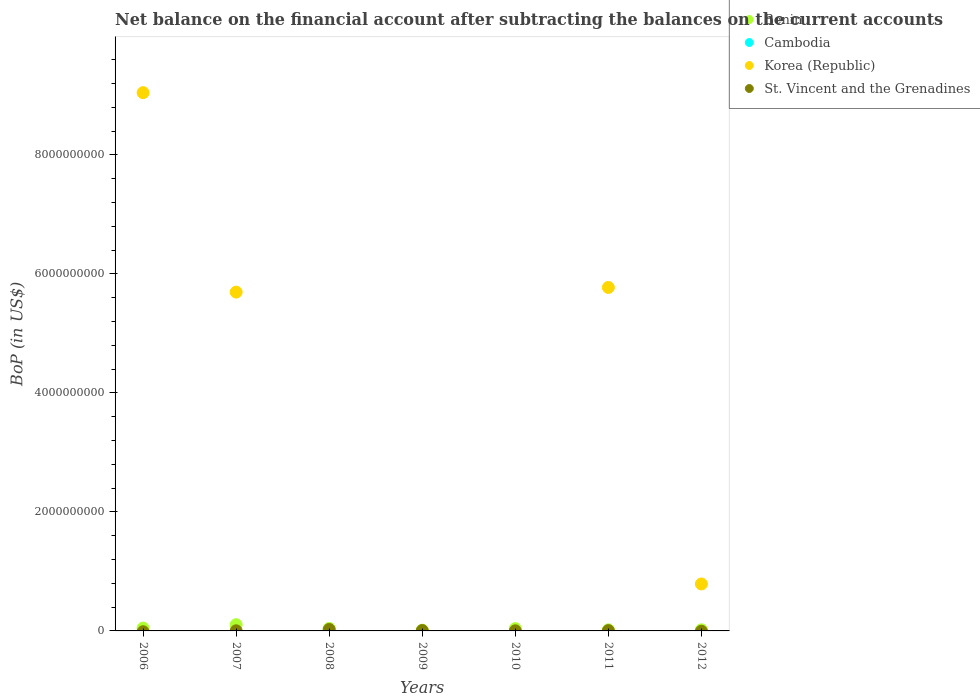How many different coloured dotlines are there?
Provide a succinct answer. 3. Is the number of dotlines equal to the number of legend labels?
Give a very brief answer. No. What is the Balance of Payments in St. Vincent and the Grenadines in 2006?
Offer a terse response. 0. Across all years, what is the maximum Balance of Payments in Korea (Republic)?
Your response must be concise. 9.05e+09. What is the total Balance of Payments in St. Vincent and the Grenadines in the graph?
Make the answer very short. 3.95e+07. What is the difference between the Balance of Payments in St. Vincent and the Grenadines in 2007 and that in 2009?
Keep it short and to the point. -4.30e+06. What is the difference between the Balance of Payments in Cambodia in 2012 and the Balance of Payments in Korea (Republic) in 2007?
Ensure brevity in your answer.  -5.69e+09. What is the average Balance of Payments in Cambodia per year?
Provide a succinct answer. 0. In the year 2012, what is the difference between the Balance of Payments in Benin and Balance of Payments in Korea (Republic)?
Keep it short and to the point. -7.71e+08. What is the ratio of the Balance of Payments in Korea (Republic) in 2007 to that in 2011?
Your answer should be very brief. 0.99. What is the difference between the highest and the second highest Balance of Payments in St. Vincent and the Grenadines?
Provide a short and direct response. 1.78e+07. What is the difference between the highest and the lowest Balance of Payments in Benin?
Your response must be concise. 9.24e+07. In how many years, is the Balance of Payments in Benin greater than the average Balance of Payments in Benin taken over all years?
Make the answer very short. 3. Is the sum of the Balance of Payments in Benin in 2007 and 2012 greater than the maximum Balance of Payments in Korea (Republic) across all years?
Keep it short and to the point. No. Does the Balance of Payments in St. Vincent and the Grenadines monotonically increase over the years?
Make the answer very short. No. Is the Balance of Payments in Cambodia strictly less than the Balance of Payments in St. Vincent and the Grenadines over the years?
Give a very brief answer. Yes. How many years are there in the graph?
Your response must be concise. 7. Are the values on the major ticks of Y-axis written in scientific E-notation?
Offer a terse response. No. How are the legend labels stacked?
Make the answer very short. Vertical. What is the title of the graph?
Your answer should be compact. Net balance on the financial account after subtracting the balances on the current accounts. What is the label or title of the Y-axis?
Provide a short and direct response. BoP (in US$). What is the BoP (in US$) in Benin in 2006?
Give a very brief answer. 4.74e+07. What is the BoP (in US$) in Cambodia in 2006?
Provide a short and direct response. 0. What is the BoP (in US$) of Korea (Republic) in 2006?
Your answer should be compact. 9.05e+09. What is the BoP (in US$) in St. Vincent and the Grenadines in 2006?
Offer a very short reply. 0. What is the BoP (in US$) of Benin in 2007?
Ensure brevity in your answer.  1.05e+08. What is the BoP (in US$) of Korea (Republic) in 2007?
Offer a terse response. 5.69e+09. What is the BoP (in US$) in St. Vincent and the Grenadines in 2007?
Give a very brief answer. 2.05e+06. What is the BoP (in US$) of Benin in 2008?
Provide a short and direct response. 4.16e+07. What is the BoP (in US$) in Cambodia in 2008?
Keep it short and to the point. 0. What is the BoP (in US$) in Korea (Republic) in 2008?
Your answer should be very brief. 0. What is the BoP (in US$) in St. Vincent and the Grenadines in 2008?
Keep it short and to the point. 2.42e+07. What is the BoP (in US$) in Benin in 2009?
Ensure brevity in your answer.  1.21e+07. What is the BoP (in US$) in Cambodia in 2009?
Ensure brevity in your answer.  0. What is the BoP (in US$) of Korea (Republic) in 2009?
Your response must be concise. 0. What is the BoP (in US$) of St. Vincent and the Grenadines in 2009?
Keep it short and to the point. 6.35e+06. What is the BoP (in US$) of Benin in 2010?
Keep it short and to the point. 3.83e+07. What is the BoP (in US$) of Korea (Republic) in 2010?
Your answer should be very brief. 0. What is the BoP (in US$) in St. Vincent and the Grenadines in 2010?
Make the answer very short. 1.79e+06. What is the BoP (in US$) in Benin in 2011?
Make the answer very short. 1.87e+07. What is the BoP (in US$) of Korea (Republic) in 2011?
Offer a very short reply. 5.77e+09. What is the BoP (in US$) of St. Vincent and the Grenadines in 2011?
Your answer should be compact. 5.15e+06. What is the BoP (in US$) of Benin in 2012?
Provide a short and direct response. 1.84e+07. What is the BoP (in US$) in Korea (Republic) in 2012?
Offer a terse response. 7.89e+08. What is the BoP (in US$) in St. Vincent and the Grenadines in 2012?
Provide a short and direct response. 0. Across all years, what is the maximum BoP (in US$) of Benin?
Provide a short and direct response. 1.05e+08. Across all years, what is the maximum BoP (in US$) of Korea (Republic)?
Your answer should be compact. 9.05e+09. Across all years, what is the maximum BoP (in US$) in St. Vincent and the Grenadines?
Provide a succinct answer. 2.42e+07. Across all years, what is the minimum BoP (in US$) of Benin?
Offer a very short reply. 1.21e+07. What is the total BoP (in US$) of Benin in the graph?
Provide a succinct answer. 2.81e+08. What is the total BoP (in US$) in Cambodia in the graph?
Keep it short and to the point. 0. What is the total BoP (in US$) in Korea (Republic) in the graph?
Make the answer very short. 2.13e+1. What is the total BoP (in US$) in St. Vincent and the Grenadines in the graph?
Provide a short and direct response. 3.95e+07. What is the difference between the BoP (in US$) in Benin in 2006 and that in 2007?
Your answer should be very brief. -5.71e+07. What is the difference between the BoP (in US$) of Korea (Republic) in 2006 and that in 2007?
Keep it short and to the point. 3.35e+09. What is the difference between the BoP (in US$) of Benin in 2006 and that in 2008?
Your answer should be very brief. 5.85e+06. What is the difference between the BoP (in US$) of Benin in 2006 and that in 2009?
Keep it short and to the point. 3.53e+07. What is the difference between the BoP (in US$) of Benin in 2006 and that in 2010?
Your answer should be very brief. 9.08e+06. What is the difference between the BoP (in US$) in Benin in 2006 and that in 2011?
Your answer should be compact. 2.87e+07. What is the difference between the BoP (in US$) in Korea (Republic) in 2006 and that in 2011?
Offer a very short reply. 3.27e+09. What is the difference between the BoP (in US$) of Benin in 2006 and that in 2012?
Your answer should be compact. 2.90e+07. What is the difference between the BoP (in US$) in Korea (Republic) in 2006 and that in 2012?
Provide a short and direct response. 8.26e+09. What is the difference between the BoP (in US$) in Benin in 2007 and that in 2008?
Offer a terse response. 6.29e+07. What is the difference between the BoP (in US$) of St. Vincent and the Grenadines in 2007 and that in 2008?
Keep it short and to the point. -2.21e+07. What is the difference between the BoP (in US$) in Benin in 2007 and that in 2009?
Offer a very short reply. 9.24e+07. What is the difference between the BoP (in US$) of St. Vincent and the Grenadines in 2007 and that in 2009?
Your response must be concise. -4.30e+06. What is the difference between the BoP (in US$) of Benin in 2007 and that in 2010?
Keep it short and to the point. 6.62e+07. What is the difference between the BoP (in US$) in St. Vincent and the Grenadines in 2007 and that in 2010?
Offer a very short reply. 2.57e+05. What is the difference between the BoP (in US$) of Benin in 2007 and that in 2011?
Offer a terse response. 8.58e+07. What is the difference between the BoP (in US$) in Korea (Republic) in 2007 and that in 2011?
Your response must be concise. -7.83e+07. What is the difference between the BoP (in US$) of St. Vincent and the Grenadines in 2007 and that in 2011?
Offer a very short reply. -3.10e+06. What is the difference between the BoP (in US$) in Benin in 2007 and that in 2012?
Your answer should be very brief. 8.61e+07. What is the difference between the BoP (in US$) of Korea (Republic) in 2007 and that in 2012?
Your response must be concise. 4.90e+09. What is the difference between the BoP (in US$) in Benin in 2008 and that in 2009?
Keep it short and to the point. 2.94e+07. What is the difference between the BoP (in US$) in St. Vincent and the Grenadines in 2008 and that in 2009?
Keep it short and to the point. 1.78e+07. What is the difference between the BoP (in US$) of Benin in 2008 and that in 2010?
Offer a very short reply. 3.22e+06. What is the difference between the BoP (in US$) of St. Vincent and the Grenadines in 2008 and that in 2010?
Make the answer very short. 2.24e+07. What is the difference between the BoP (in US$) in Benin in 2008 and that in 2011?
Offer a terse response. 2.28e+07. What is the difference between the BoP (in US$) in St. Vincent and the Grenadines in 2008 and that in 2011?
Provide a succinct answer. 1.90e+07. What is the difference between the BoP (in US$) in Benin in 2008 and that in 2012?
Make the answer very short. 2.32e+07. What is the difference between the BoP (in US$) of Benin in 2009 and that in 2010?
Offer a very short reply. -2.62e+07. What is the difference between the BoP (in US$) in St. Vincent and the Grenadines in 2009 and that in 2010?
Make the answer very short. 4.56e+06. What is the difference between the BoP (in US$) of Benin in 2009 and that in 2011?
Provide a short and direct response. -6.57e+06. What is the difference between the BoP (in US$) of St. Vincent and the Grenadines in 2009 and that in 2011?
Your answer should be very brief. 1.20e+06. What is the difference between the BoP (in US$) in Benin in 2009 and that in 2012?
Keep it short and to the point. -6.25e+06. What is the difference between the BoP (in US$) in Benin in 2010 and that in 2011?
Ensure brevity in your answer.  1.96e+07. What is the difference between the BoP (in US$) of St. Vincent and the Grenadines in 2010 and that in 2011?
Your answer should be very brief. -3.36e+06. What is the difference between the BoP (in US$) of Benin in 2010 and that in 2012?
Provide a short and direct response. 1.99e+07. What is the difference between the BoP (in US$) of Benin in 2011 and that in 2012?
Give a very brief answer. 3.23e+05. What is the difference between the BoP (in US$) in Korea (Republic) in 2011 and that in 2012?
Provide a short and direct response. 4.98e+09. What is the difference between the BoP (in US$) of Benin in 2006 and the BoP (in US$) of Korea (Republic) in 2007?
Offer a very short reply. -5.65e+09. What is the difference between the BoP (in US$) in Benin in 2006 and the BoP (in US$) in St. Vincent and the Grenadines in 2007?
Your answer should be very brief. 4.54e+07. What is the difference between the BoP (in US$) of Korea (Republic) in 2006 and the BoP (in US$) of St. Vincent and the Grenadines in 2007?
Provide a succinct answer. 9.04e+09. What is the difference between the BoP (in US$) of Benin in 2006 and the BoP (in US$) of St. Vincent and the Grenadines in 2008?
Ensure brevity in your answer.  2.32e+07. What is the difference between the BoP (in US$) in Korea (Republic) in 2006 and the BoP (in US$) in St. Vincent and the Grenadines in 2008?
Ensure brevity in your answer.  9.02e+09. What is the difference between the BoP (in US$) in Benin in 2006 and the BoP (in US$) in St. Vincent and the Grenadines in 2009?
Provide a short and direct response. 4.11e+07. What is the difference between the BoP (in US$) in Korea (Republic) in 2006 and the BoP (in US$) in St. Vincent and the Grenadines in 2009?
Your answer should be very brief. 9.04e+09. What is the difference between the BoP (in US$) in Benin in 2006 and the BoP (in US$) in St. Vincent and the Grenadines in 2010?
Provide a succinct answer. 4.56e+07. What is the difference between the BoP (in US$) of Korea (Republic) in 2006 and the BoP (in US$) of St. Vincent and the Grenadines in 2010?
Provide a short and direct response. 9.04e+09. What is the difference between the BoP (in US$) of Benin in 2006 and the BoP (in US$) of Korea (Republic) in 2011?
Offer a very short reply. -5.72e+09. What is the difference between the BoP (in US$) in Benin in 2006 and the BoP (in US$) in St. Vincent and the Grenadines in 2011?
Provide a succinct answer. 4.23e+07. What is the difference between the BoP (in US$) in Korea (Republic) in 2006 and the BoP (in US$) in St. Vincent and the Grenadines in 2011?
Make the answer very short. 9.04e+09. What is the difference between the BoP (in US$) in Benin in 2006 and the BoP (in US$) in Korea (Republic) in 2012?
Offer a very short reply. -7.42e+08. What is the difference between the BoP (in US$) in Benin in 2007 and the BoP (in US$) in St. Vincent and the Grenadines in 2008?
Offer a very short reply. 8.03e+07. What is the difference between the BoP (in US$) in Korea (Republic) in 2007 and the BoP (in US$) in St. Vincent and the Grenadines in 2008?
Your answer should be very brief. 5.67e+09. What is the difference between the BoP (in US$) in Benin in 2007 and the BoP (in US$) in St. Vincent and the Grenadines in 2009?
Provide a succinct answer. 9.82e+07. What is the difference between the BoP (in US$) of Korea (Republic) in 2007 and the BoP (in US$) of St. Vincent and the Grenadines in 2009?
Ensure brevity in your answer.  5.69e+09. What is the difference between the BoP (in US$) in Benin in 2007 and the BoP (in US$) in St. Vincent and the Grenadines in 2010?
Provide a succinct answer. 1.03e+08. What is the difference between the BoP (in US$) of Korea (Republic) in 2007 and the BoP (in US$) of St. Vincent and the Grenadines in 2010?
Offer a terse response. 5.69e+09. What is the difference between the BoP (in US$) of Benin in 2007 and the BoP (in US$) of Korea (Republic) in 2011?
Keep it short and to the point. -5.67e+09. What is the difference between the BoP (in US$) of Benin in 2007 and the BoP (in US$) of St. Vincent and the Grenadines in 2011?
Your response must be concise. 9.94e+07. What is the difference between the BoP (in US$) in Korea (Republic) in 2007 and the BoP (in US$) in St. Vincent and the Grenadines in 2011?
Make the answer very short. 5.69e+09. What is the difference between the BoP (in US$) of Benin in 2007 and the BoP (in US$) of Korea (Republic) in 2012?
Your answer should be very brief. -6.85e+08. What is the difference between the BoP (in US$) of Benin in 2008 and the BoP (in US$) of St. Vincent and the Grenadines in 2009?
Your answer should be compact. 3.52e+07. What is the difference between the BoP (in US$) in Benin in 2008 and the BoP (in US$) in St. Vincent and the Grenadines in 2010?
Ensure brevity in your answer.  3.98e+07. What is the difference between the BoP (in US$) in Benin in 2008 and the BoP (in US$) in Korea (Republic) in 2011?
Provide a short and direct response. -5.73e+09. What is the difference between the BoP (in US$) of Benin in 2008 and the BoP (in US$) of St. Vincent and the Grenadines in 2011?
Your answer should be very brief. 3.64e+07. What is the difference between the BoP (in US$) of Benin in 2008 and the BoP (in US$) of Korea (Republic) in 2012?
Make the answer very short. -7.48e+08. What is the difference between the BoP (in US$) of Benin in 2009 and the BoP (in US$) of St. Vincent and the Grenadines in 2010?
Your response must be concise. 1.04e+07. What is the difference between the BoP (in US$) of Benin in 2009 and the BoP (in US$) of Korea (Republic) in 2011?
Ensure brevity in your answer.  -5.76e+09. What is the difference between the BoP (in US$) in Benin in 2009 and the BoP (in US$) in St. Vincent and the Grenadines in 2011?
Keep it short and to the point. 7.00e+06. What is the difference between the BoP (in US$) in Benin in 2009 and the BoP (in US$) in Korea (Republic) in 2012?
Provide a succinct answer. -7.77e+08. What is the difference between the BoP (in US$) of Benin in 2010 and the BoP (in US$) of Korea (Republic) in 2011?
Keep it short and to the point. -5.73e+09. What is the difference between the BoP (in US$) in Benin in 2010 and the BoP (in US$) in St. Vincent and the Grenadines in 2011?
Keep it short and to the point. 3.32e+07. What is the difference between the BoP (in US$) in Benin in 2010 and the BoP (in US$) in Korea (Republic) in 2012?
Offer a very short reply. -7.51e+08. What is the difference between the BoP (in US$) in Benin in 2011 and the BoP (in US$) in Korea (Republic) in 2012?
Offer a very short reply. -7.70e+08. What is the average BoP (in US$) of Benin per year?
Your answer should be compact. 4.02e+07. What is the average BoP (in US$) of Cambodia per year?
Give a very brief answer. 0. What is the average BoP (in US$) in Korea (Republic) per year?
Ensure brevity in your answer.  3.04e+09. What is the average BoP (in US$) in St. Vincent and the Grenadines per year?
Your answer should be very brief. 5.64e+06. In the year 2006, what is the difference between the BoP (in US$) in Benin and BoP (in US$) in Korea (Republic)?
Your answer should be compact. -9.00e+09. In the year 2007, what is the difference between the BoP (in US$) of Benin and BoP (in US$) of Korea (Republic)?
Provide a succinct answer. -5.59e+09. In the year 2007, what is the difference between the BoP (in US$) in Benin and BoP (in US$) in St. Vincent and the Grenadines?
Provide a succinct answer. 1.02e+08. In the year 2007, what is the difference between the BoP (in US$) of Korea (Republic) and BoP (in US$) of St. Vincent and the Grenadines?
Offer a terse response. 5.69e+09. In the year 2008, what is the difference between the BoP (in US$) of Benin and BoP (in US$) of St. Vincent and the Grenadines?
Offer a very short reply. 1.74e+07. In the year 2009, what is the difference between the BoP (in US$) of Benin and BoP (in US$) of St. Vincent and the Grenadines?
Make the answer very short. 5.80e+06. In the year 2010, what is the difference between the BoP (in US$) in Benin and BoP (in US$) in St. Vincent and the Grenadines?
Your answer should be compact. 3.66e+07. In the year 2011, what is the difference between the BoP (in US$) of Benin and BoP (in US$) of Korea (Republic)?
Provide a short and direct response. -5.75e+09. In the year 2011, what is the difference between the BoP (in US$) in Benin and BoP (in US$) in St. Vincent and the Grenadines?
Your answer should be compact. 1.36e+07. In the year 2011, what is the difference between the BoP (in US$) of Korea (Republic) and BoP (in US$) of St. Vincent and the Grenadines?
Give a very brief answer. 5.77e+09. In the year 2012, what is the difference between the BoP (in US$) of Benin and BoP (in US$) of Korea (Republic)?
Give a very brief answer. -7.71e+08. What is the ratio of the BoP (in US$) of Benin in 2006 to that in 2007?
Keep it short and to the point. 0.45. What is the ratio of the BoP (in US$) in Korea (Republic) in 2006 to that in 2007?
Provide a succinct answer. 1.59. What is the ratio of the BoP (in US$) of Benin in 2006 to that in 2008?
Keep it short and to the point. 1.14. What is the ratio of the BoP (in US$) in Benin in 2006 to that in 2009?
Make the answer very short. 3.9. What is the ratio of the BoP (in US$) of Benin in 2006 to that in 2010?
Offer a very short reply. 1.24. What is the ratio of the BoP (in US$) of Benin in 2006 to that in 2011?
Keep it short and to the point. 2.53. What is the ratio of the BoP (in US$) of Korea (Republic) in 2006 to that in 2011?
Make the answer very short. 1.57. What is the ratio of the BoP (in US$) in Benin in 2006 to that in 2012?
Make the answer very short. 2.58. What is the ratio of the BoP (in US$) in Korea (Republic) in 2006 to that in 2012?
Ensure brevity in your answer.  11.46. What is the ratio of the BoP (in US$) of Benin in 2007 to that in 2008?
Ensure brevity in your answer.  2.51. What is the ratio of the BoP (in US$) of St. Vincent and the Grenadines in 2007 to that in 2008?
Your answer should be very brief. 0.08. What is the ratio of the BoP (in US$) of Benin in 2007 to that in 2009?
Keep it short and to the point. 8.6. What is the ratio of the BoP (in US$) of St. Vincent and the Grenadines in 2007 to that in 2009?
Your answer should be very brief. 0.32. What is the ratio of the BoP (in US$) of Benin in 2007 to that in 2010?
Give a very brief answer. 2.73. What is the ratio of the BoP (in US$) of St. Vincent and the Grenadines in 2007 to that in 2010?
Offer a terse response. 1.14. What is the ratio of the BoP (in US$) of Benin in 2007 to that in 2011?
Make the answer very short. 5.58. What is the ratio of the BoP (in US$) of Korea (Republic) in 2007 to that in 2011?
Your response must be concise. 0.99. What is the ratio of the BoP (in US$) in St. Vincent and the Grenadines in 2007 to that in 2011?
Your answer should be compact. 0.4. What is the ratio of the BoP (in US$) of Benin in 2007 to that in 2012?
Your answer should be very brief. 5.68. What is the ratio of the BoP (in US$) in Korea (Republic) in 2007 to that in 2012?
Your answer should be compact. 7.22. What is the ratio of the BoP (in US$) of Benin in 2008 to that in 2009?
Make the answer very short. 3.42. What is the ratio of the BoP (in US$) in St. Vincent and the Grenadines in 2008 to that in 2009?
Provide a succinct answer. 3.81. What is the ratio of the BoP (in US$) in Benin in 2008 to that in 2010?
Your response must be concise. 1.08. What is the ratio of the BoP (in US$) of St. Vincent and the Grenadines in 2008 to that in 2010?
Your answer should be very brief. 13.51. What is the ratio of the BoP (in US$) in Benin in 2008 to that in 2011?
Ensure brevity in your answer.  2.22. What is the ratio of the BoP (in US$) in St. Vincent and the Grenadines in 2008 to that in 2011?
Give a very brief answer. 4.7. What is the ratio of the BoP (in US$) of Benin in 2008 to that in 2012?
Keep it short and to the point. 2.26. What is the ratio of the BoP (in US$) of Benin in 2009 to that in 2010?
Provide a succinct answer. 0.32. What is the ratio of the BoP (in US$) in St. Vincent and the Grenadines in 2009 to that in 2010?
Provide a short and direct response. 3.55. What is the ratio of the BoP (in US$) in Benin in 2009 to that in 2011?
Make the answer very short. 0.65. What is the ratio of the BoP (in US$) in St. Vincent and the Grenadines in 2009 to that in 2011?
Provide a succinct answer. 1.23. What is the ratio of the BoP (in US$) in Benin in 2009 to that in 2012?
Offer a very short reply. 0.66. What is the ratio of the BoP (in US$) in Benin in 2010 to that in 2011?
Offer a terse response. 2.05. What is the ratio of the BoP (in US$) in St. Vincent and the Grenadines in 2010 to that in 2011?
Your response must be concise. 0.35. What is the ratio of the BoP (in US$) of Benin in 2010 to that in 2012?
Offer a terse response. 2.08. What is the ratio of the BoP (in US$) in Benin in 2011 to that in 2012?
Your response must be concise. 1.02. What is the ratio of the BoP (in US$) of Korea (Republic) in 2011 to that in 2012?
Your response must be concise. 7.31. What is the difference between the highest and the second highest BoP (in US$) in Benin?
Offer a very short reply. 5.71e+07. What is the difference between the highest and the second highest BoP (in US$) in Korea (Republic)?
Your answer should be compact. 3.27e+09. What is the difference between the highest and the second highest BoP (in US$) of St. Vincent and the Grenadines?
Ensure brevity in your answer.  1.78e+07. What is the difference between the highest and the lowest BoP (in US$) in Benin?
Your response must be concise. 9.24e+07. What is the difference between the highest and the lowest BoP (in US$) of Korea (Republic)?
Provide a short and direct response. 9.05e+09. What is the difference between the highest and the lowest BoP (in US$) in St. Vincent and the Grenadines?
Offer a terse response. 2.42e+07. 